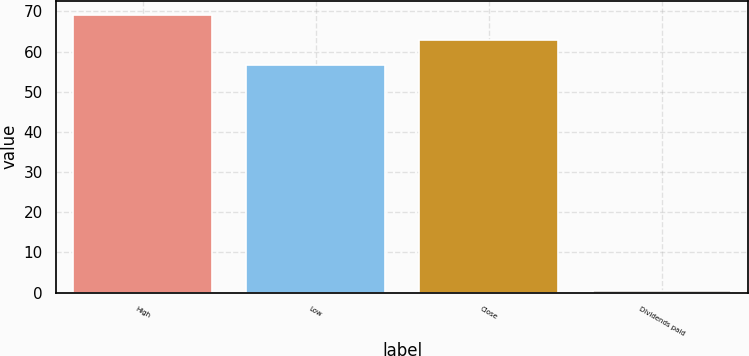Convert chart. <chart><loc_0><loc_0><loc_500><loc_500><bar_chart><fcel>High<fcel>Low<fcel>Close<fcel>Dividends paid<nl><fcel>69.15<fcel>56.53<fcel>62.84<fcel>0.34<nl></chart> 